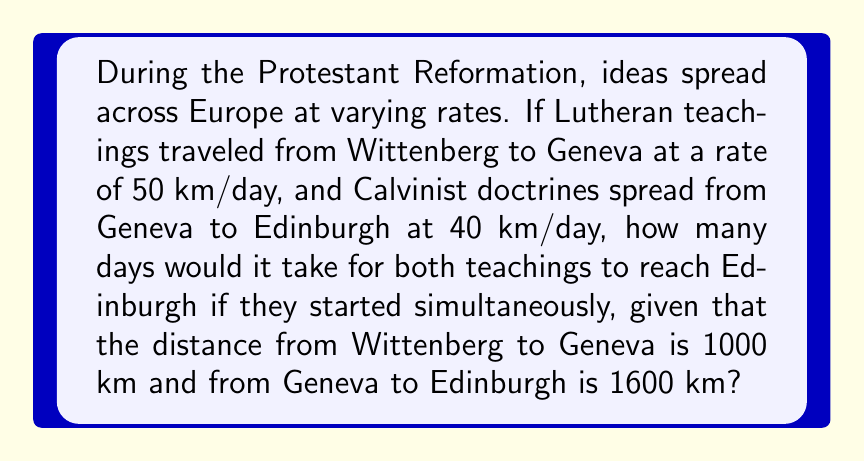What is the answer to this math problem? Let's approach this step-by-step using distance-time equations:

1) For Lutheran teachings:
   Distance from Wittenberg to Geneva = 1000 km
   Rate = 50 km/day
   Time = Distance / Rate
   $t_1 = \frac{1000}{50} = 20$ days

2) For Calvinist doctrines:
   Distance from Geneva to Edinburgh = 1600 km
   Rate = 40 km/day
   Time = Distance / Rate
   $t_2 = \frac{1600}{40} = 40$ days

3) Total time for Lutheran teachings to reach Edinburgh:
   $t_{total} = t_1 + t_2 = 20 + 40 = 60$ days

4) Calvinist doctrines start from Geneva, so they only need time $t_2$:
   $t_{Calvinist} = 40$ days

5) Since both start simultaneously, the time for both to reach Edinburgh is the maximum of these two times:

   $t_{final} = \max(t_{total}, t_{Calvinist}) = \max(60, 40) = 60$ days

Therefore, it would take 60 days for both teachings to reach Edinburgh.
Answer: 60 days 